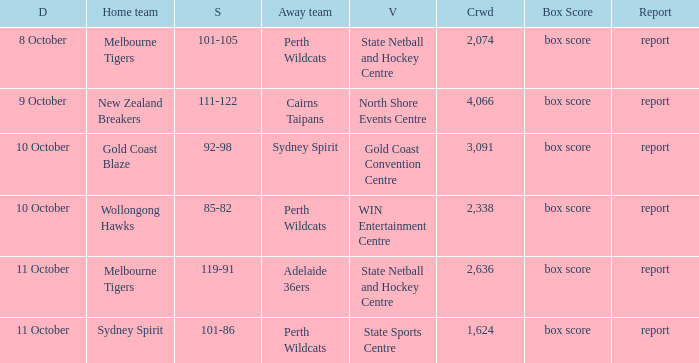What was the average crowd size for the game when the Gold Coast Blaze was the home team? 3091.0. 